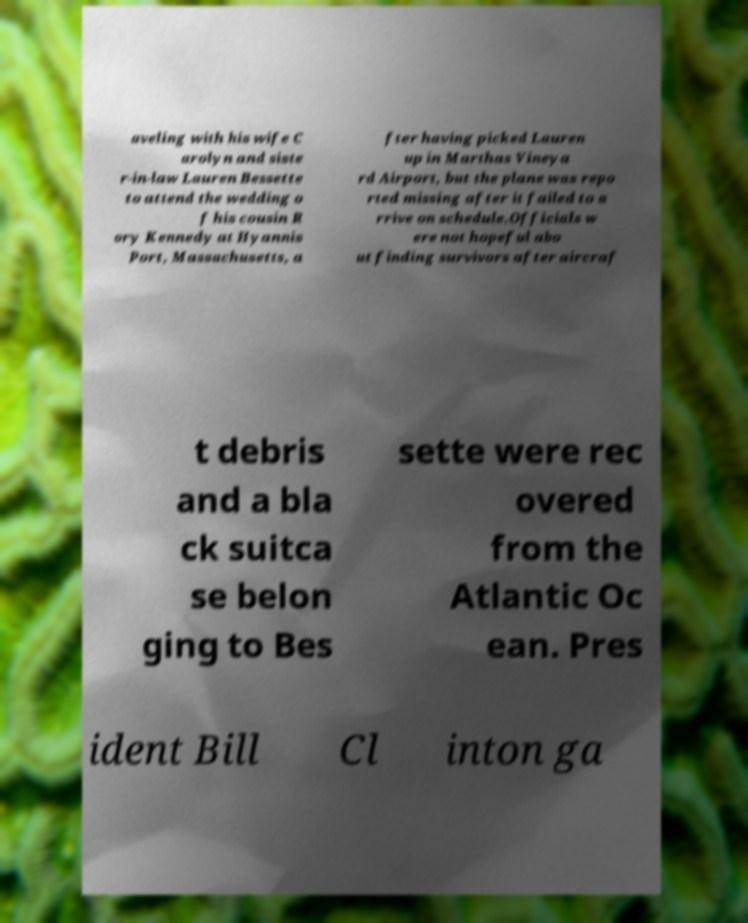Could you assist in decoding the text presented in this image and type it out clearly? aveling with his wife C arolyn and siste r-in-law Lauren Bessette to attend the wedding o f his cousin R ory Kennedy at Hyannis Port, Massachusetts, a fter having picked Lauren up in Marthas Vineya rd Airport, but the plane was repo rted missing after it failed to a rrive on schedule.Officials w ere not hopeful abo ut finding survivors after aircraf t debris and a bla ck suitca se belon ging to Bes sette were rec overed from the Atlantic Oc ean. Pres ident Bill Cl inton ga 